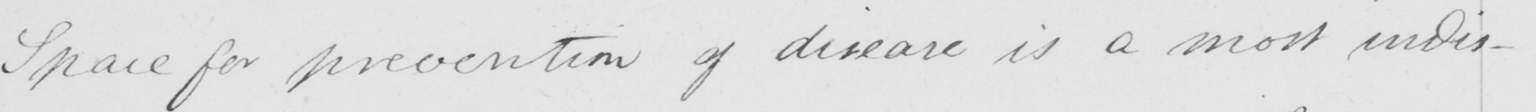What does this handwritten line say? Space for prevention of disease is a most indis- 